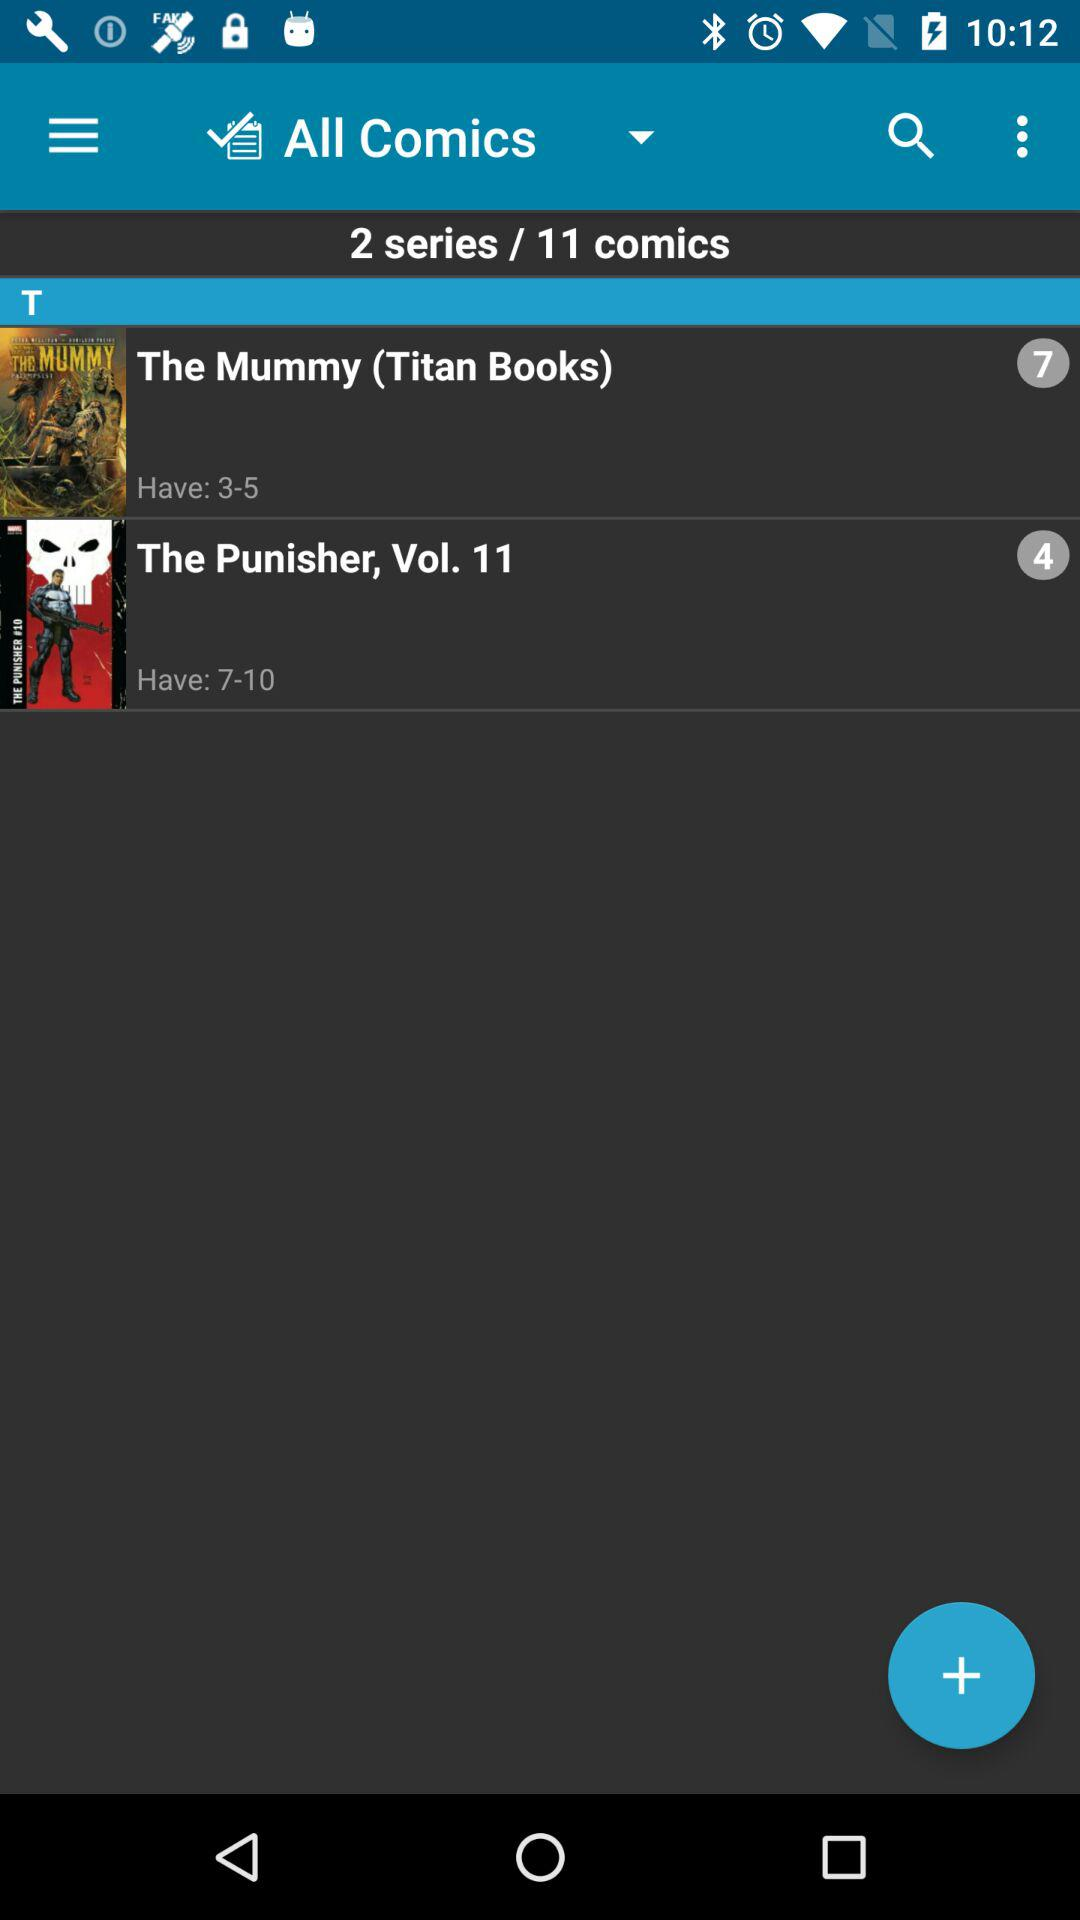What is the number of series? The number of series is 2. 